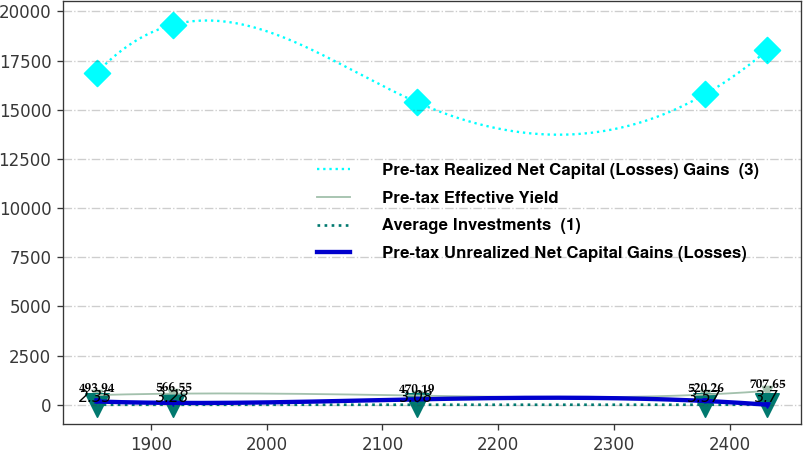Convert chart. <chart><loc_0><loc_0><loc_500><loc_500><line_chart><ecel><fcel>Pre-tax Realized Net Capital (Losses) Gains  (3)<fcel>Pre-tax Effective Yield<fcel>Average Investments  (1)<fcel>Pre-tax Unrealized Net Capital Gains (Losses)<nl><fcel>1853.22<fcel>16872.4<fcel>493.94<fcel>2.35<fcel>169.29<nl><fcel>1919.33<fcel>19325.3<fcel>566.55<fcel>3.28<fcel>97.45<nl><fcel>2129.59<fcel>15386.8<fcel>470.19<fcel>3.08<fcel>277.31<nl><fcel>2378.25<fcel>15780.6<fcel>520.26<fcel>3.57<fcel>196.38<nl><fcel>2432.2<fcel>18027.6<fcel>707.65<fcel>3.7<fcel>6.36<nl></chart> 